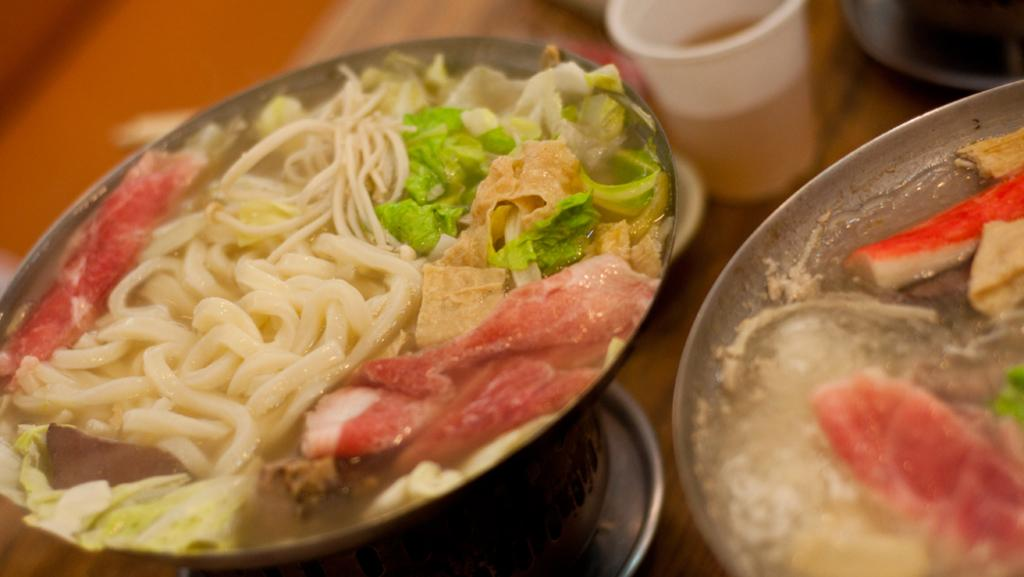What type of food is in the bowl in the image? There is a spaghetti bowl with meat and veggies in the image. What other food item is visible in the image? There is a plate of food beside the spaghetti bowl. Where are the plate of food and the spaghetti bowl located? The plate of food and the spaghetti bowl are on a table. What is the purpose of the glass on the table? The glass on the table might be used for holding a beverage. What type of sea creature can be seen crawling on the table in the image? There are no sea creatures present in the image; it features a spaghetti bowl, a plate of food, and a glass on a table. What is the purpose of the crack in the table in the image? There is no crack present in the table in the image. 